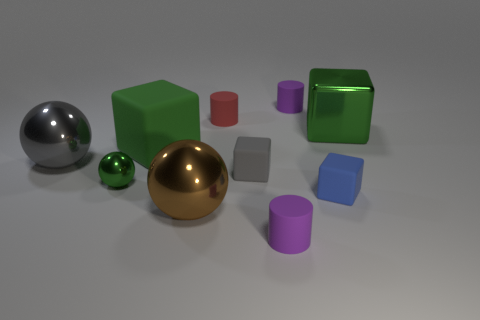Subtract all red cylinders. How many cylinders are left? 2 Add 1 green rubber objects. How many green rubber objects are left? 2 Add 5 small yellow rubber blocks. How many small yellow rubber blocks exist? 5 Subtract all gray cubes. How many cubes are left? 3 Subtract 0 blue cylinders. How many objects are left? 10 Subtract all cylinders. How many objects are left? 7 Subtract 1 balls. How many balls are left? 2 Subtract all blue cubes. Subtract all red cylinders. How many cubes are left? 3 Subtract all red cubes. How many red cylinders are left? 1 Subtract all blue matte blocks. Subtract all small spheres. How many objects are left? 8 